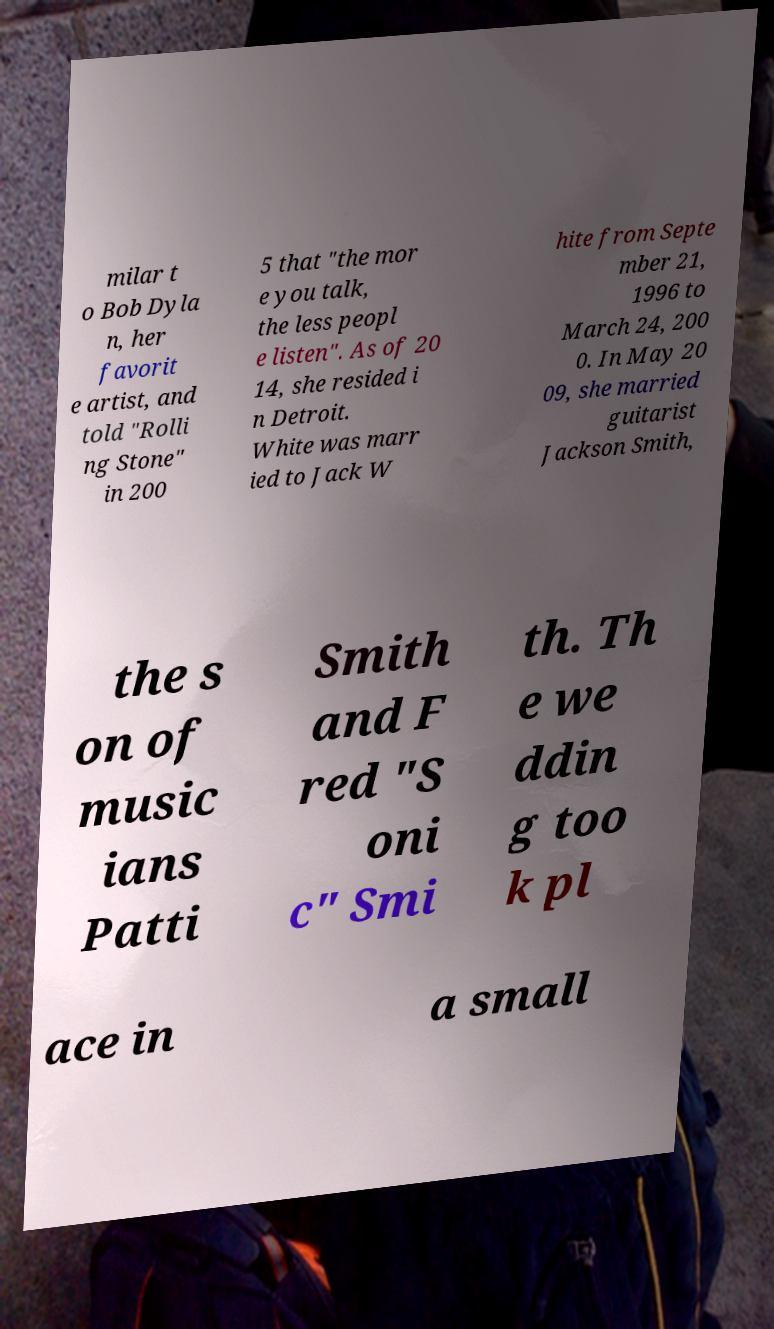Could you assist in decoding the text presented in this image and type it out clearly? milar t o Bob Dyla n, her favorit e artist, and told "Rolli ng Stone" in 200 5 that "the mor e you talk, the less peopl e listen". As of 20 14, she resided i n Detroit. White was marr ied to Jack W hite from Septe mber 21, 1996 to March 24, 200 0. In May 20 09, she married guitarist Jackson Smith, the s on of music ians Patti Smith and F red "S oni c" Smi th. Th e we ddin g too k pl ace in a small 